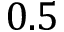Convert formula to latex. <formula><loc_0><loc_0><loc_500><loc_500>0 . 5</formula> 